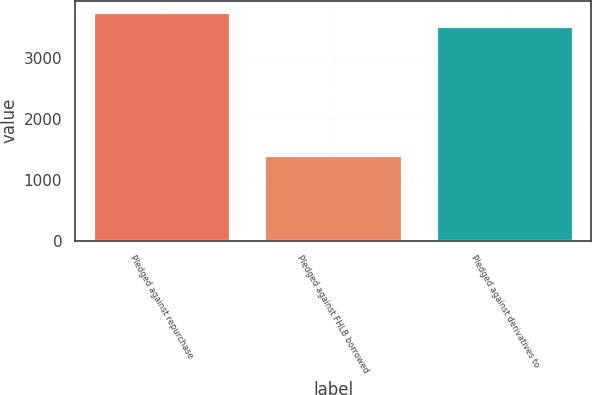Convert chart to OTSL. <chart><loc_0><loc_0><loc_500><loc_500><bar_chart><fcel>Pledged against repurchase<fcel>Pledged against FHLB borrowed<fcel>Pledged against derivatives to<nl><fcel>3749.4<fcel>1407<fcel>3520<nl></chart> 